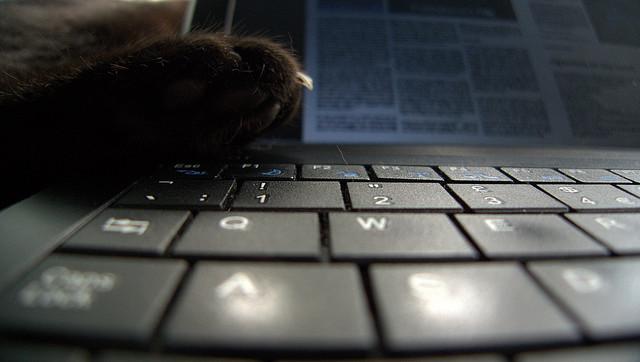What type of electronic device is this?
Concise answer only. Laptop. Is the cat typing on the computer?
Keep it brief. No. Is the screen on?
Be succinct. Yes. What is the screen for?
Short answer required. Laptop. What color is the keyboard?
Quick response, please. Black. 